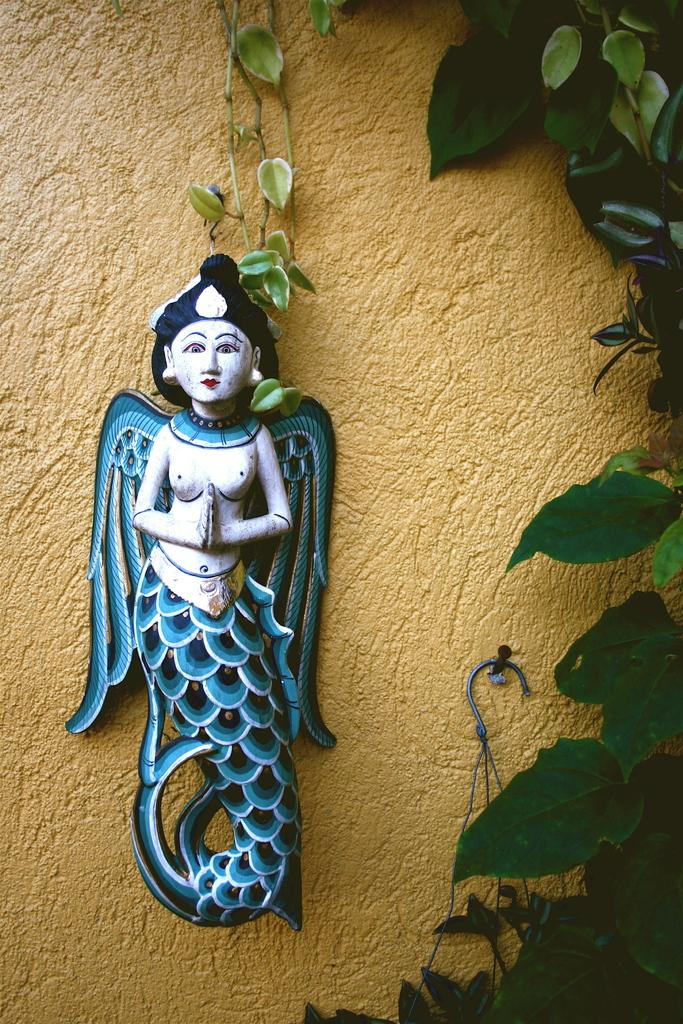What is attached to the wall in the image? There is a sculpture attached to the wall in the image. What can be seen on the right side of the image? Leaves are visible on the right side of the image. What is the purpose of the hook attached to the wall in the middle of the image? The purpose of the hook is not specified in the image, but it could be used for hanging or attaching objects. How many toes can be seen on the boy in the image? There is no boy present in the image, so it is not possible to determine the number of toes. 